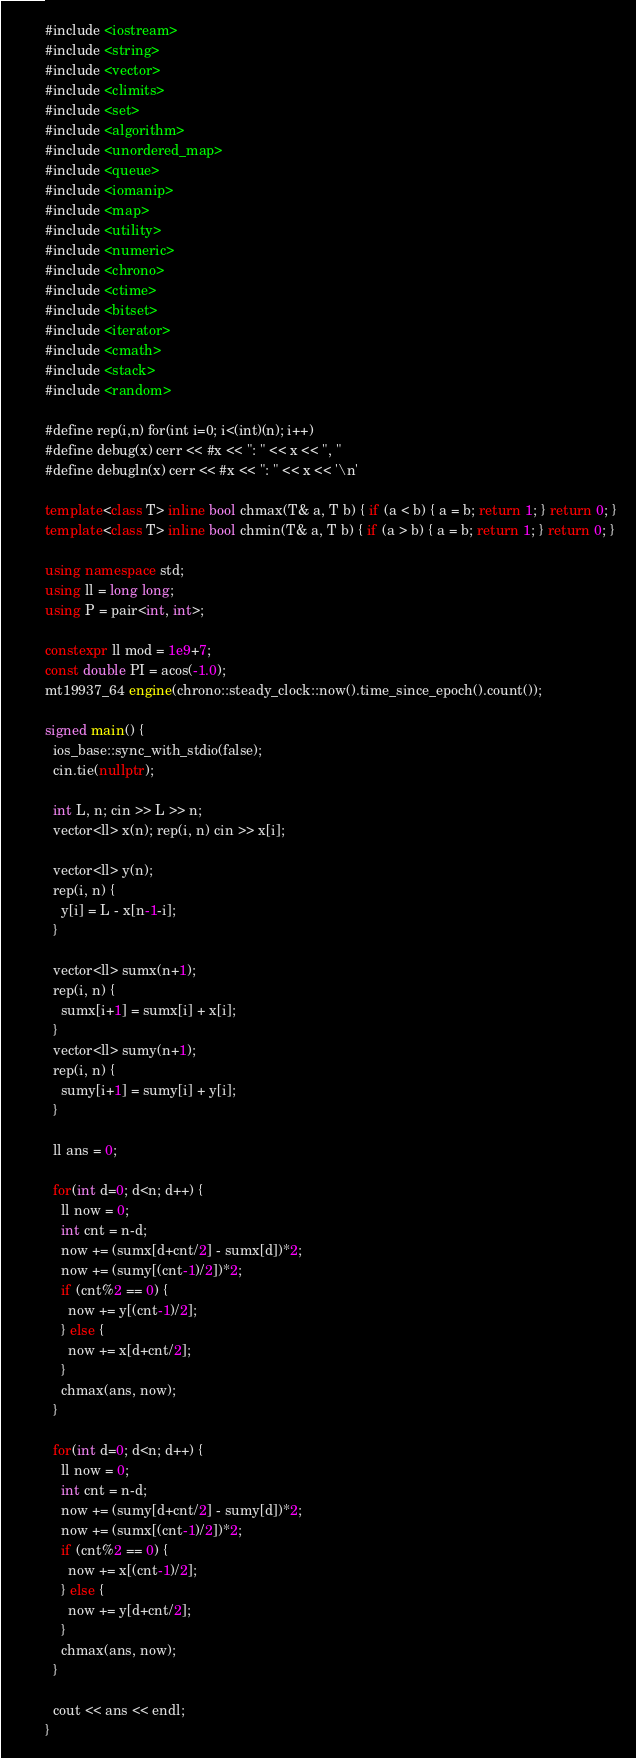Convert code to text. <code><loc_0><loc_0><loc_500><loc_500><_C++_>#include <iostream>
#include <string>
#include <vector>
#include <climits>
#include <set>
#include <algorithm>
#include <unordered_map>
#include <queue>
#include <iomanip>
#include <map>
#include <utility>
#include <numeric>
#include <chrono>
#include <ctime>
#include <bitset>
#include <iterator>
#include <cmath>
#include <stack>
#include <random>

#define rep(i,n) for(int i=0; i<(int)(n); i++)
#define debug(x) cerr << #x << ": " << x << ", "
#define debugln(x) cerr << #x << ": " << x << '\n'

template<class T> inline bool chmax(T& a, T b) { if (a < b) { a = b; return 1; } return 0; }
template<class T> inline bool chmin(T& a, T b) { if (a > b) { a = b; return 1; } return 0; }

using namespace std;
using ll = long long;
using P = pair<int, int>;

constexpr ll mod = 1e9+7;
const double PI = acos(-1.0);
mt19937_64 engine(chrono::steady_clock::now().time_since_epoch().count());

signed main() {
  ios_base::sync_with_stdio(false);
  cin.tie(nullptr);

  int L, n; cin >> L >> n;
  vector<ll> x(n); rep(i, n) cin >> x[i];

  vector<ll> y(n);
  rep(i, n) {
    y[i] = L - x[n-1-i];
  }

  vector<ll> sumx(n+1);
  rep(i, n) {
    sumx[i+1] = sumx[i] + x[i];
  }
  vector<ll> sumy(n+1);
  rep(i, n) {
    sumy[i+1] = sumy[i] + y[i];
  }

  ll ans = 0;

  for(int d=0; d<n; d++) {
    ll now = 0;
    int cnt = n-d;
    now += (sumx[d+cnt/2] - sumx[d])*2;
    now += (sumy[(cnt-1)/2])*2;
    if (cnt%2 == 0) {
      now += y[(cnt-1)/2];
    } else {
      now += x[d+cnt/2];
    }
    chmax(ans, now);
  }

  for(int d=0; d<n; d++) {
    ll now = 0;
    int cnt = n-d;
    now += (sumy[d+cnt/2] - sumy[d])*2;
    now += (sumx[(cnt-1)/2])*2;
    if (cnt%2 == 0) {
      now += x[(cnt-1)/2];
    } else {
      now += y[d+cnt/2];
    }
    chmax(ans, now);
  }

  cout << ans << endl;
}
</code> 